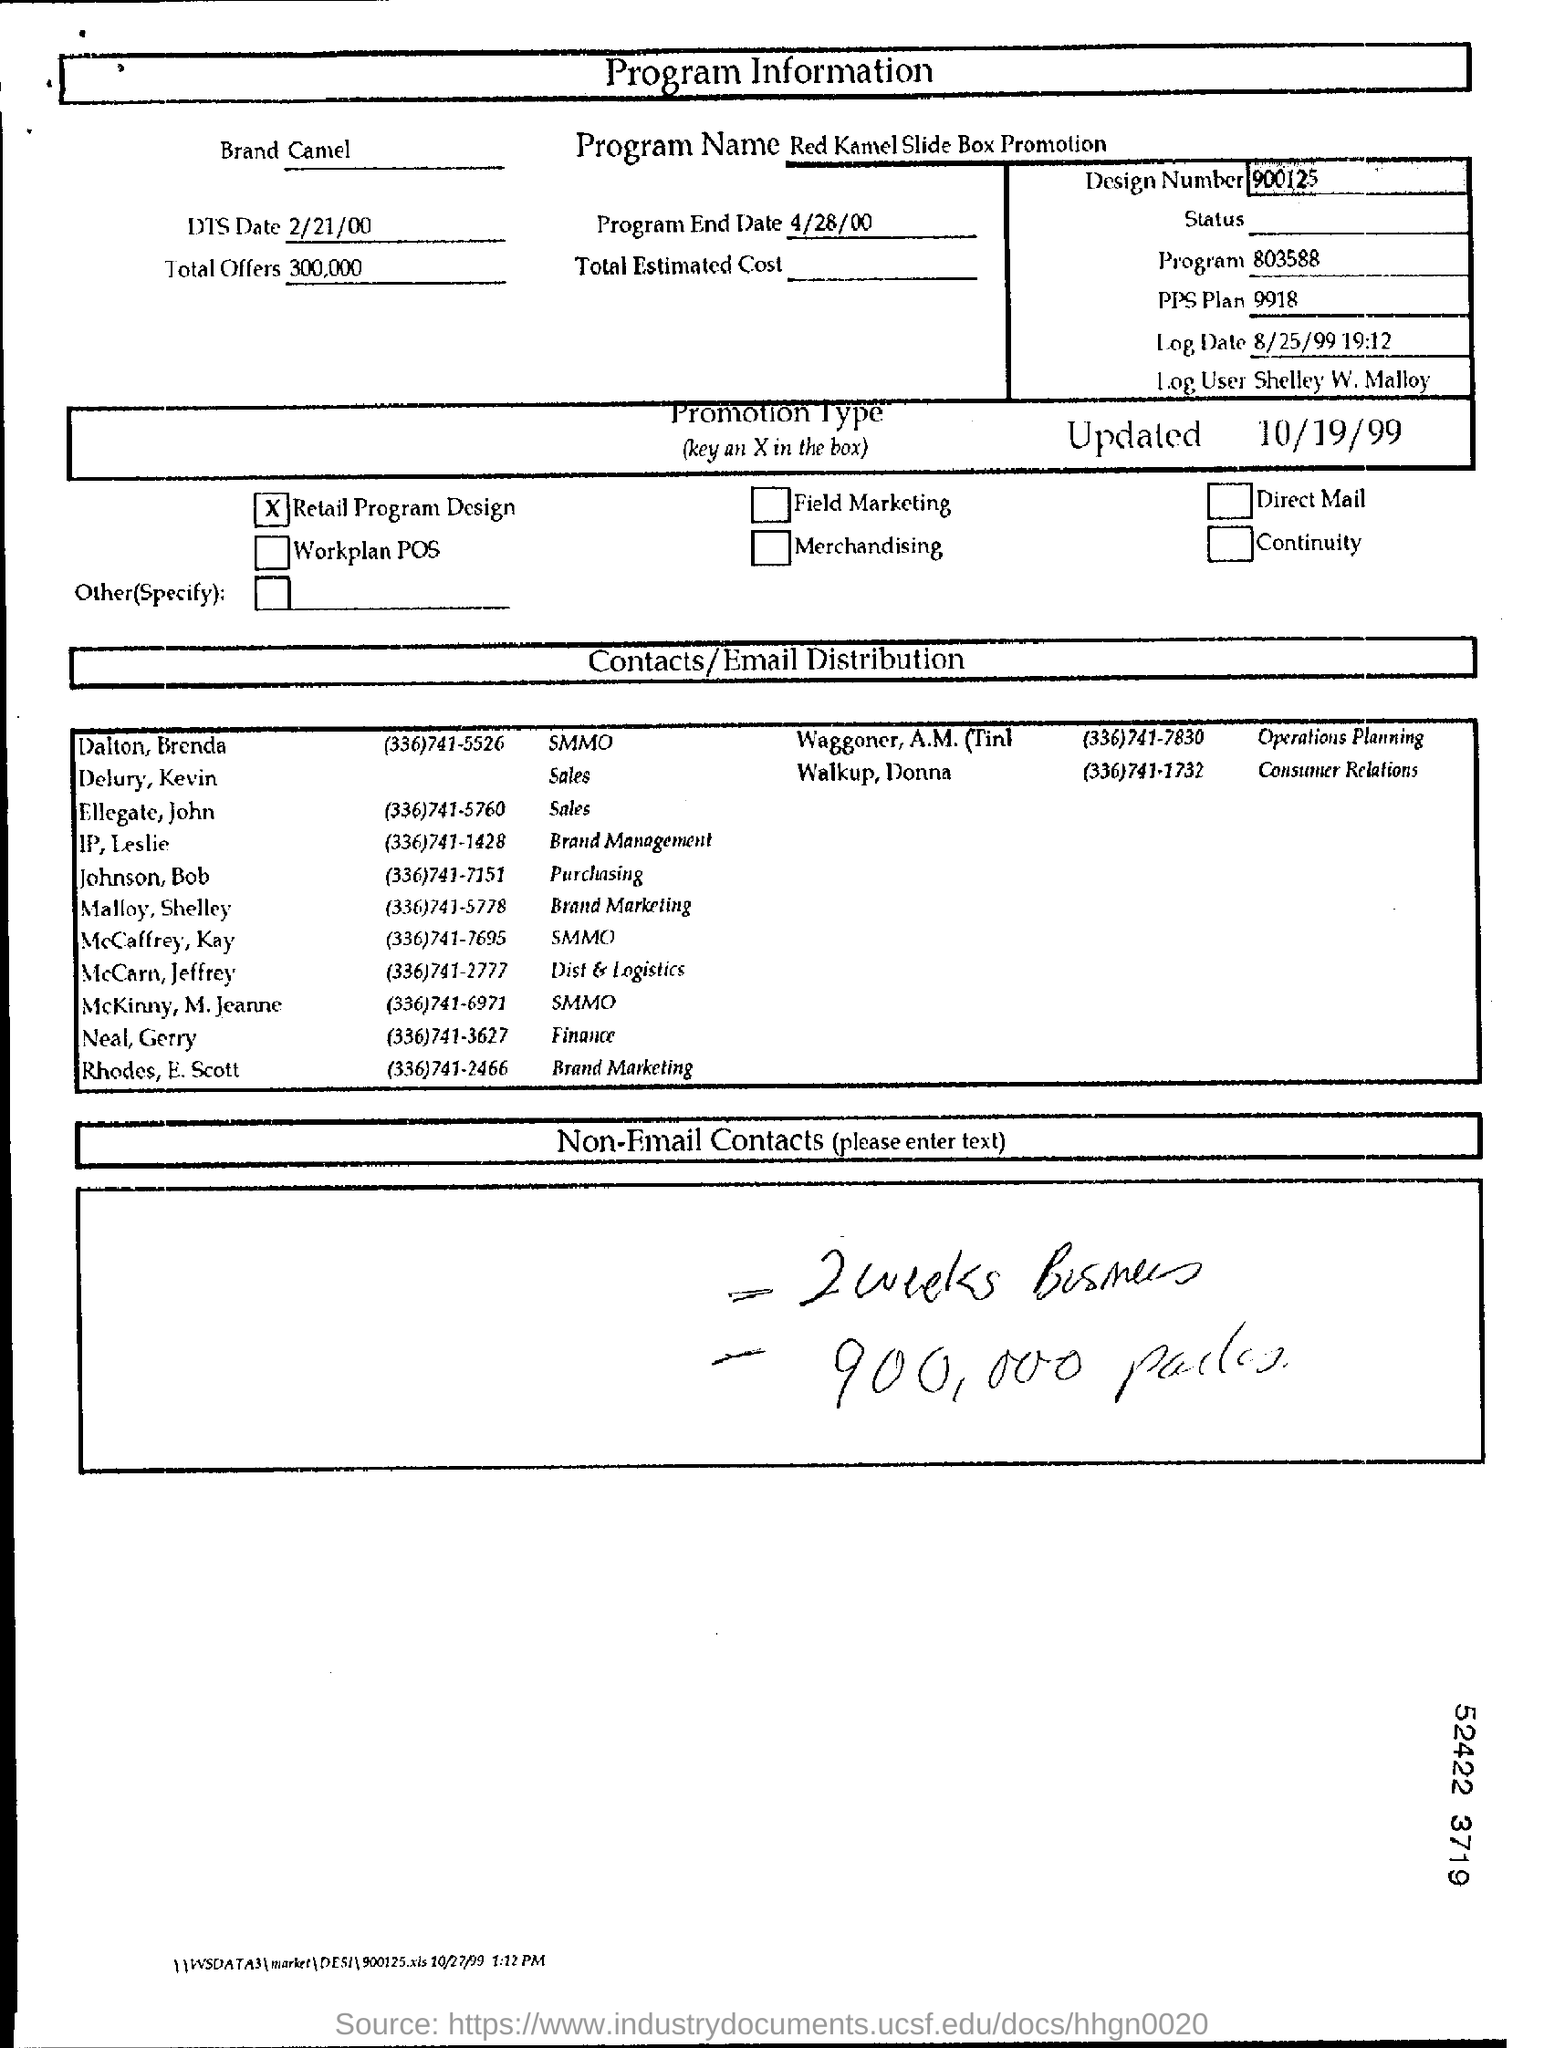Give some essential details in this illustration. The design number is 900125. The PPS Plan, also known as 9918, is a detailed and comprehensive plan that provides information about a specific topic. The date of DTS is February 21, 2000. The program's name is Red Kamel Slide Box Promotion. There are a total of 300,000 offers. 